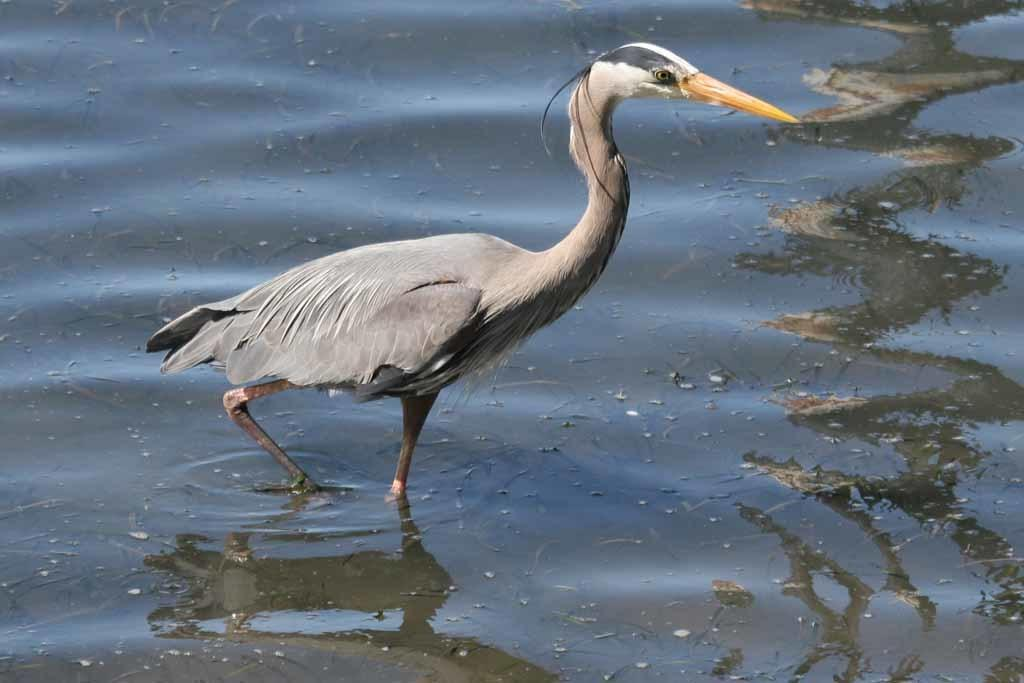What type of animal can be seen in the image? There is a bird in the image. Where is the bird located? The bird is standing in a river. How many beds can be seen in the image? There are no beds present in the image; it features a bird standing in a river. What type of cheese is hanging from the bird's beak in the image? There is no cheese present in the image; it only features a bird standing in a river. 